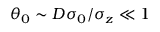Convert formula to latex. <formula><loc_0><loc_0><loc_500><loc_500>\theta _ { 0 } \sim D \sigma _ { 0 } / \sigma _ { z } \ll 1</formula> 